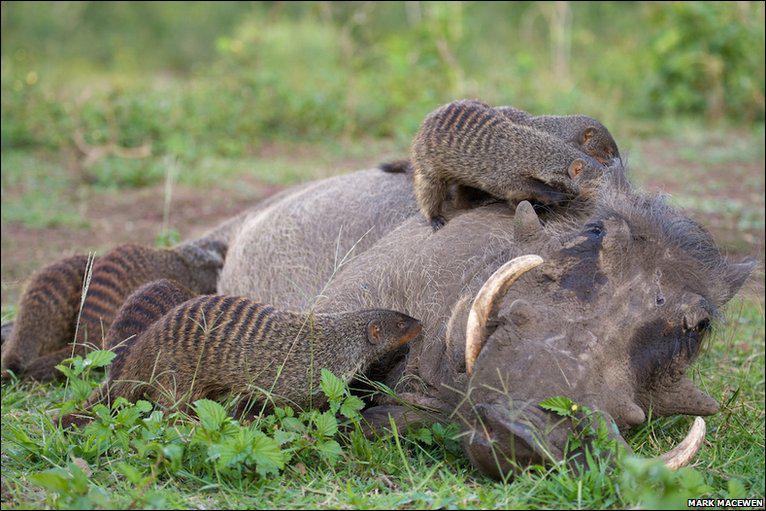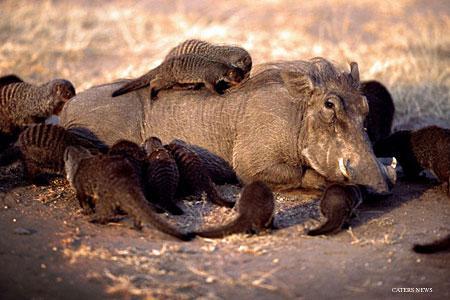The first image is the image on the left, the second image is the image on the right. Evaluate the accuracy of this statement regarding the images: "the right pic has three or less animals". Is it true? Answer yes or no. No. 